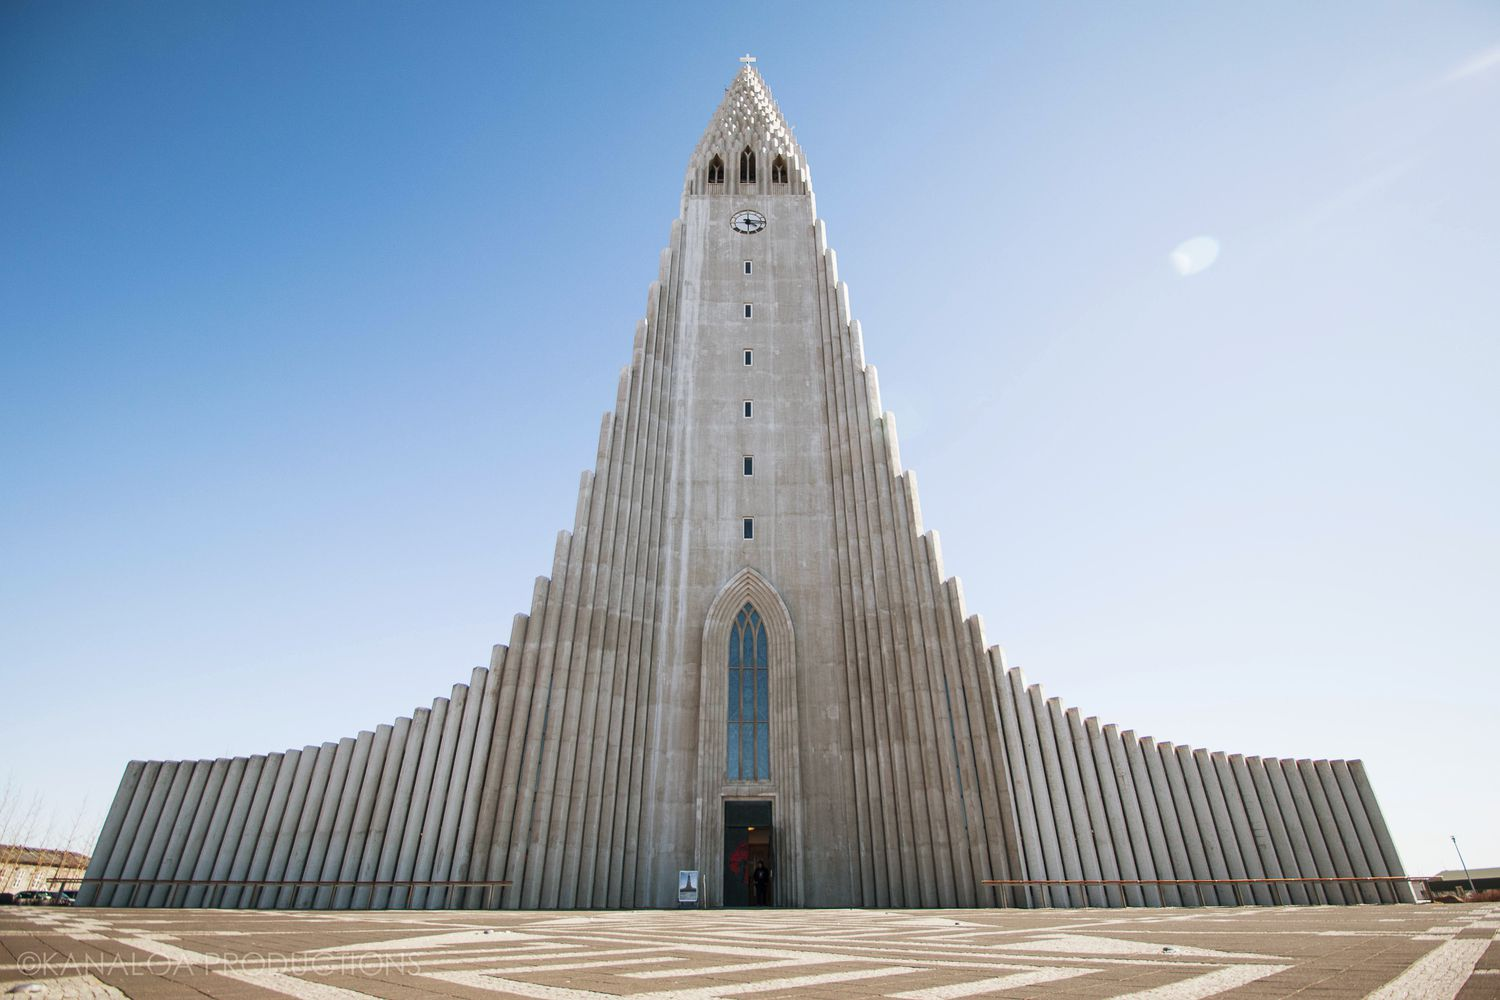What is this photo about'? The image captures the majestic Hallgrímskirkja, a renowned Lutheran parish church located in Reykjavík, Iceland. The church stands tall against the backdrop of a clear blue sky, its pointed structure reaching towards the heavens. The exterior of the church is gray, a stark contrast to the vibrant blue of the sky. The photo is taken from a low angle, which emphasizes the height and grandeur of the church. The architecture of the church is characterized by a series of vertical lines, culminating in a pointed tower at the top. The entrance to the church is marked by a red door, above which a small cross is visible. The image conveys a sense of tranquility and reverence, befitting the sacred nature of the landmark. 